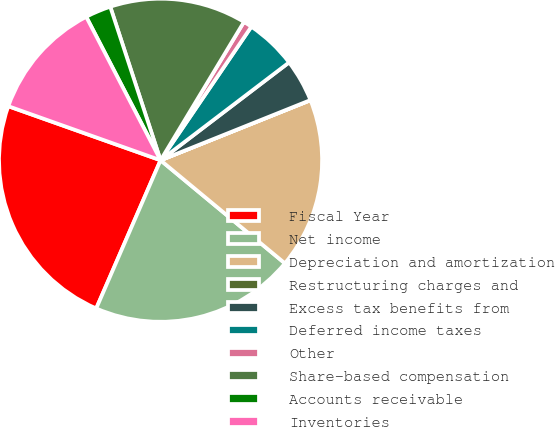Convert chart to OTSL. <chart><loc_0><loc_0><loc_500><loc_500><pie_chart><fcel>Fiscal Year<fcel>Net income<fcel>Depreciation and amortization<fcel>Restructuring charges and<fcel>Excess tax benefits from<fcel>Deferred income taxes<fcel>Other<fcel>Share-based compensation<fcel>Accounts receivable<fcel>Inventories<nl><fcel>23.91%<fcel>20.5%<fcel>17.08%<fcel>0.01%<fcel>4.28%<fcel>5.14%<fcel>0.87%<fcel>13.67%<fcel>2.57%<fcel>11.96%<nl></chart> 